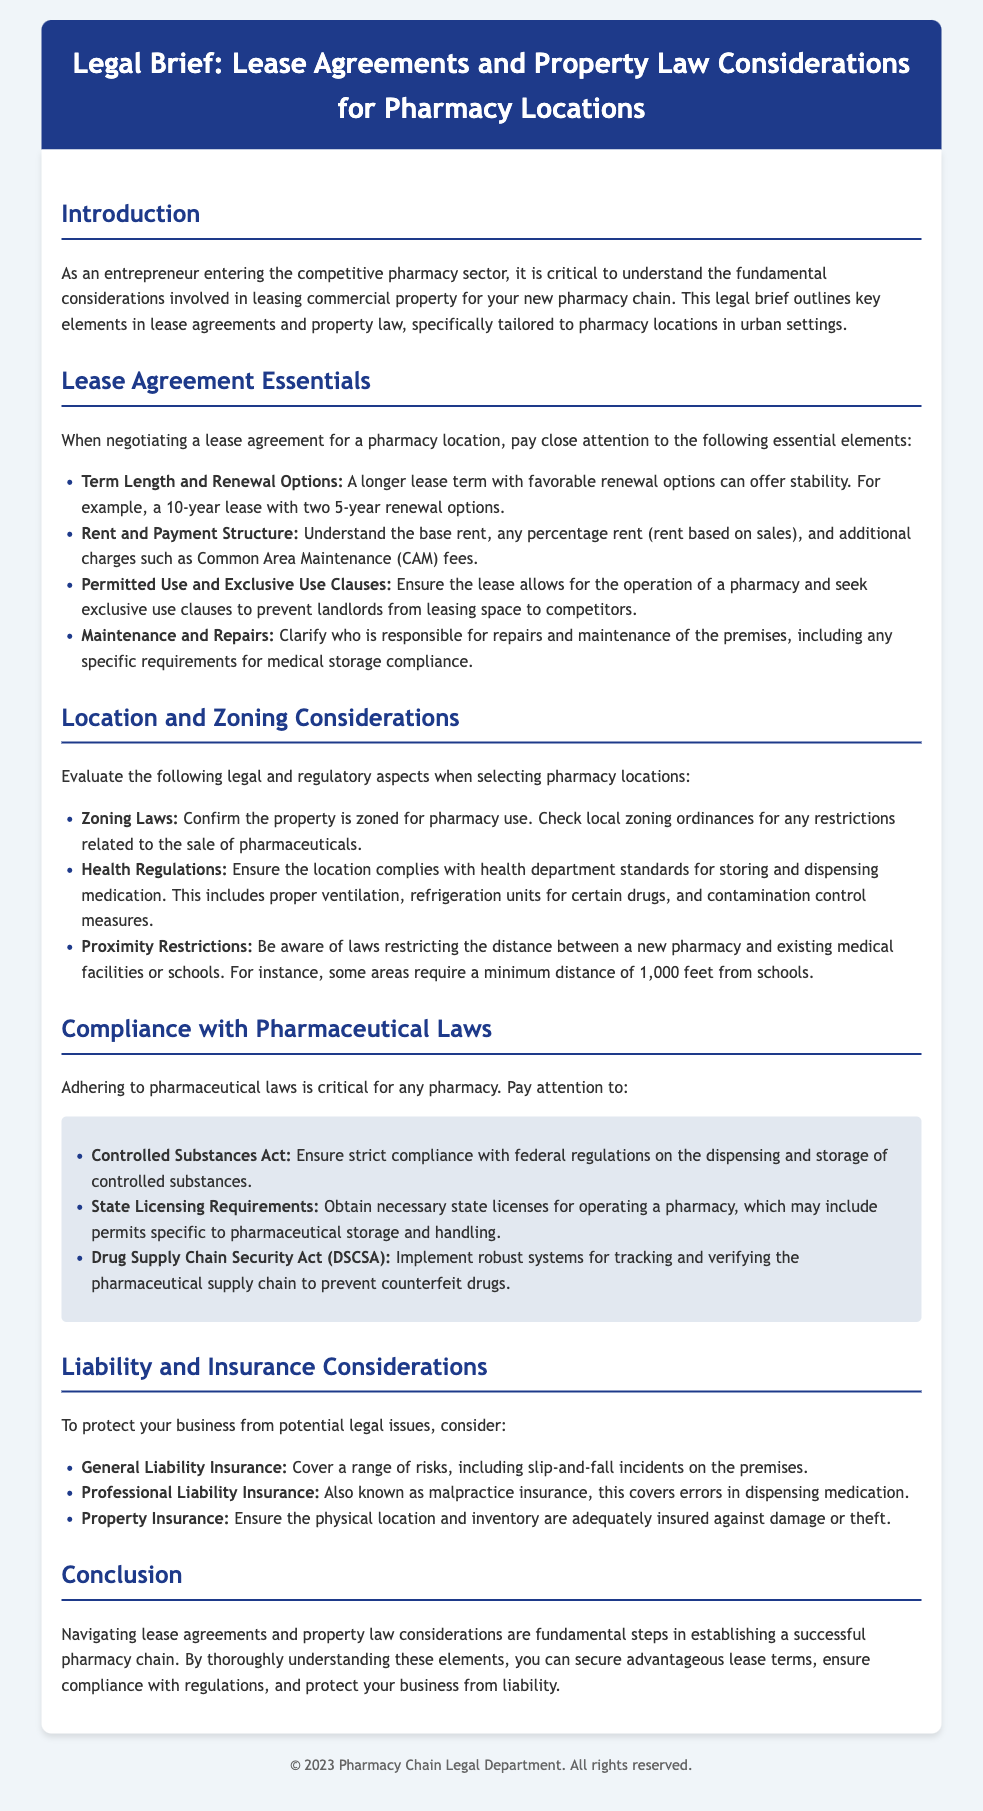What is the main focus of this legal brief? The main focus of the legal brief is understanding lease agreements and property law considerations for pharmacy locations.
Answer: Lease agreements and property law considerations for pharmacy locations What is the suggested term length for a lease? The document suggests a longer lease term, such as a 10-year lease with two 5-year renewal options.
Answer: A 10-year lease What are the three types of insurance mentioned? The brief lists general liability insurance, professional liability insurance, and property insurance.
Answer: General liability, professional liability, property What should be confirmed regarding the property? It should be confirmed that the property is zoned for pharmacy use.
Answer: Zoning for pharmacy use What is a requirement related to the distance from schools? The document mentions laws that may require a minimum distance of 1,000 feet from schools for pharmacies.
Answer: 1,000 feet What act relates to controlled substances compliance? The Controlled Substances Act is crucial for compliance with federal regulations on controlled substances.
Answer: Controlled Substances Act What is one aspect of maintenance responsibilities mentioned? The lease should clarify who is responsible for repairs and maintenance of the premises.
Answer: Responsibility for repairs and maintenance What is a potential effect of exclusive use clauses? Exclusive use clauses can prevent landlords from leasing space to competitors.
Answer: Prevent leasing to competitors 